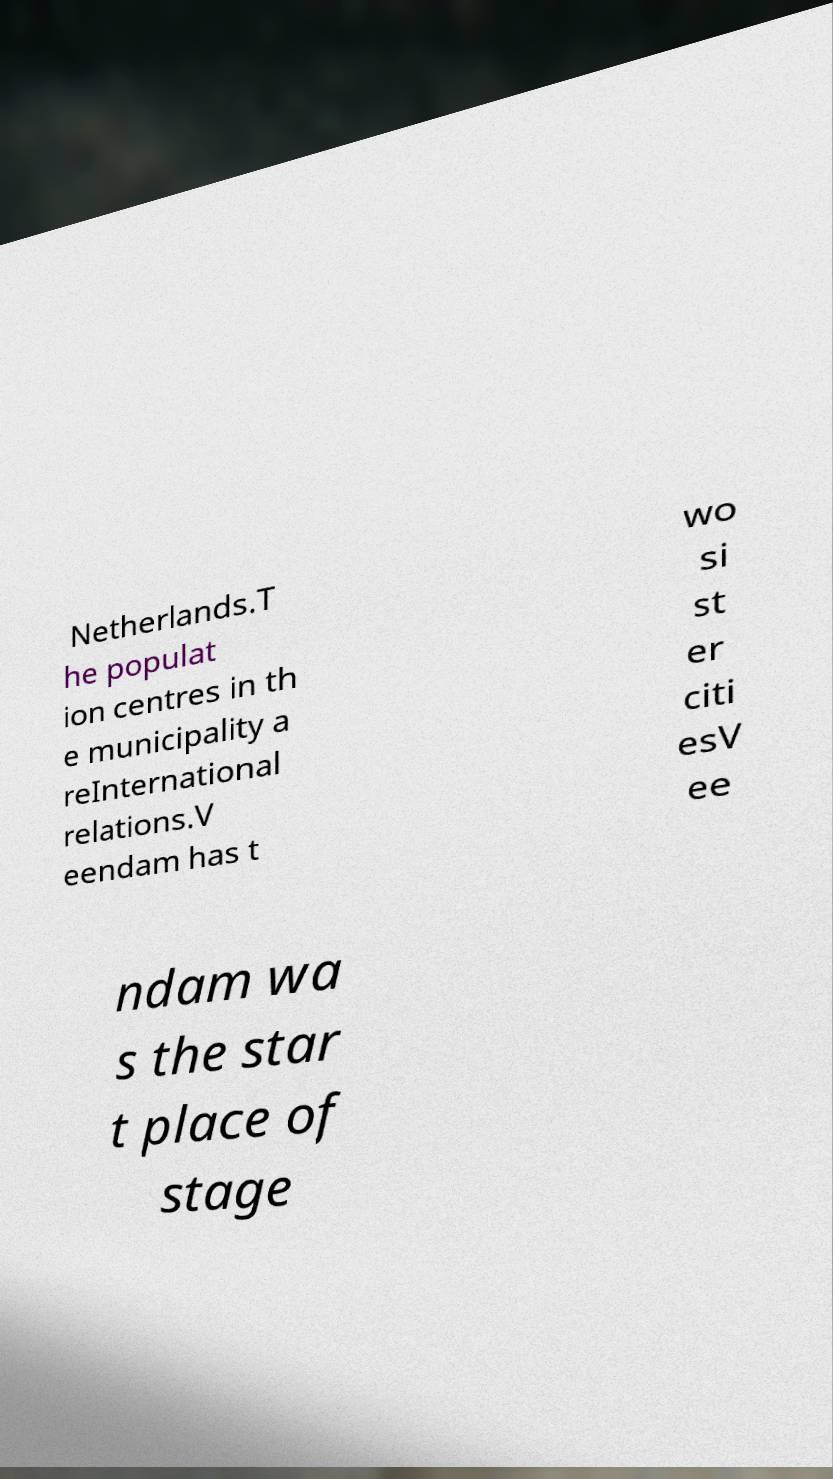Please identify and transcribe the text found in this image. Netherlands.T he populat ion centres in th e municipality a reInternational relations.V eendam has t wo si st er citi esV ee ndam wa s the star t place of stage 